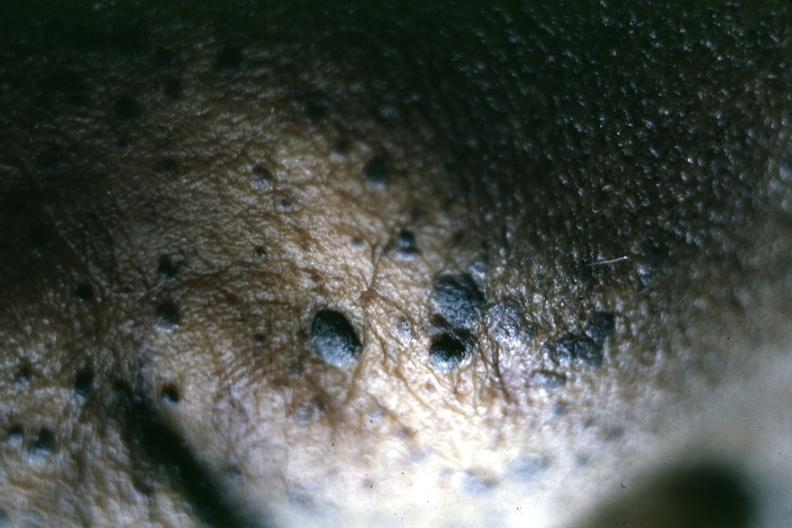what is well shown?
Answer the question using a single word or phrase. Close-up of typical lesions perspective of elevated pasted on lesions 